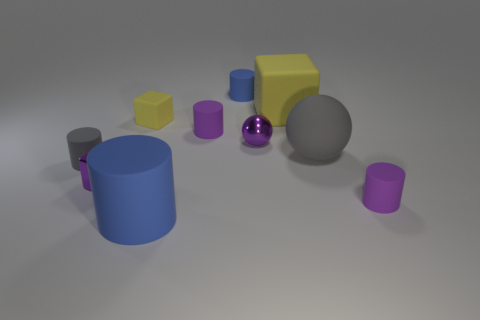Subtract 2 cylinders. How many cylinders are left? 3 Subtract all blocks. How many objects are left? 7 Add 2 blue objects. How many blue objects exist? 4 Subtract 0 cyan cylinders. How many objects are left? 10 Subtract all gray things. Subtract all large matte cylinders. How many objects are left? 7 Add 6 shiny spheres. How many shiny spheres are left? 7 